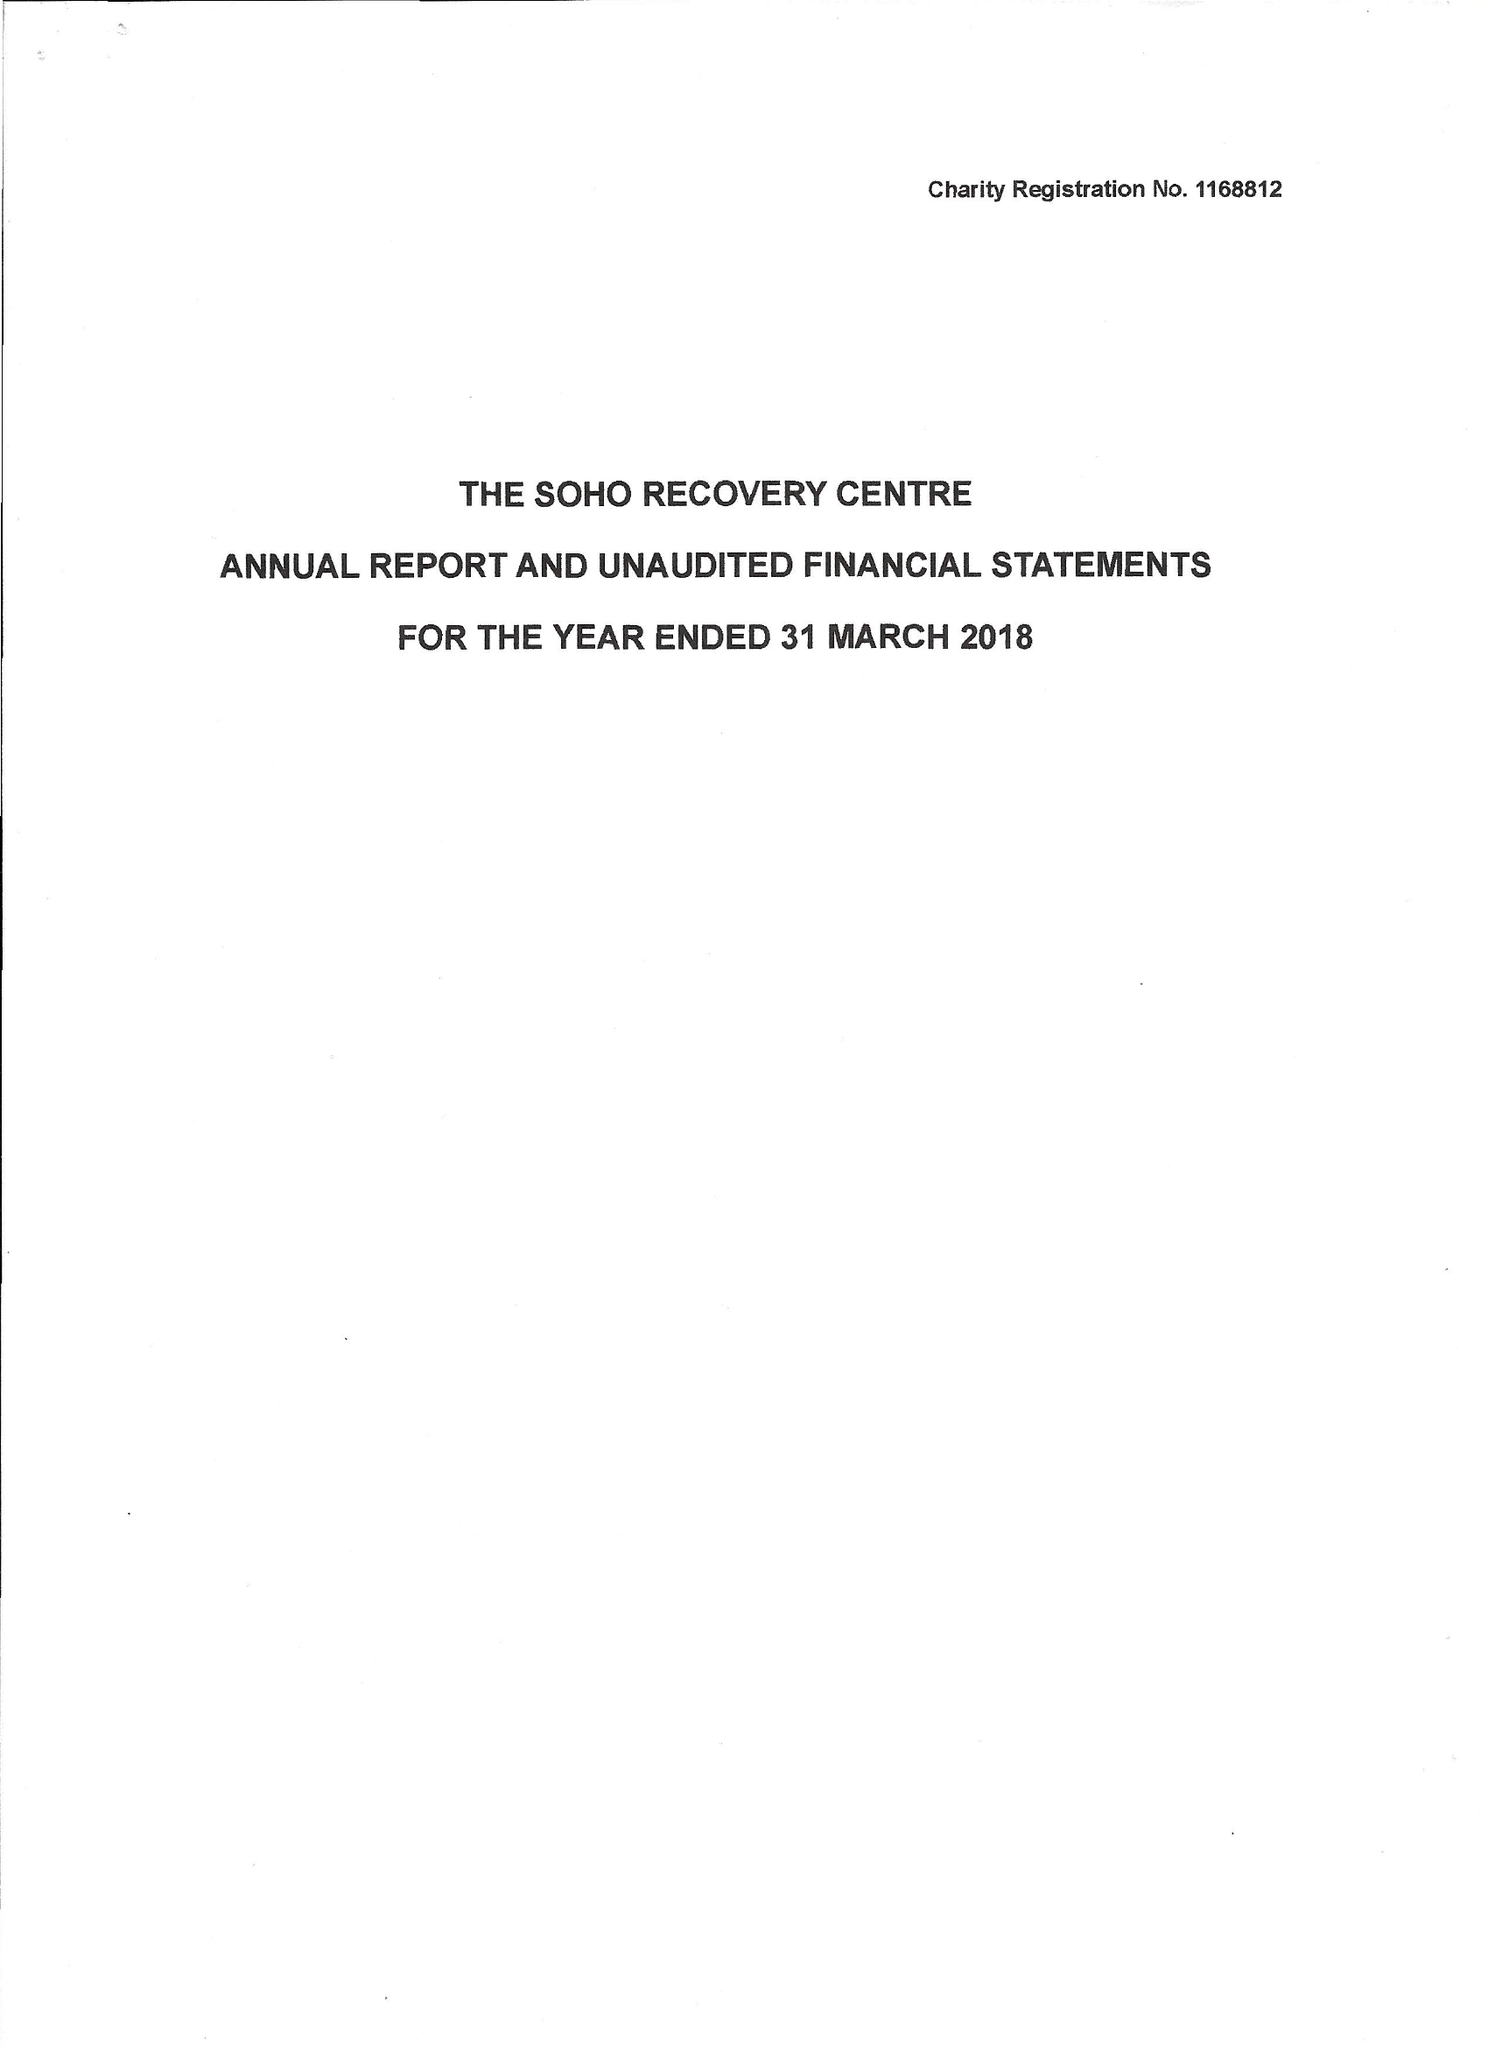What is the value for the address__postcode?
Answer the question using a single word or phrase. WC2H 0EW 